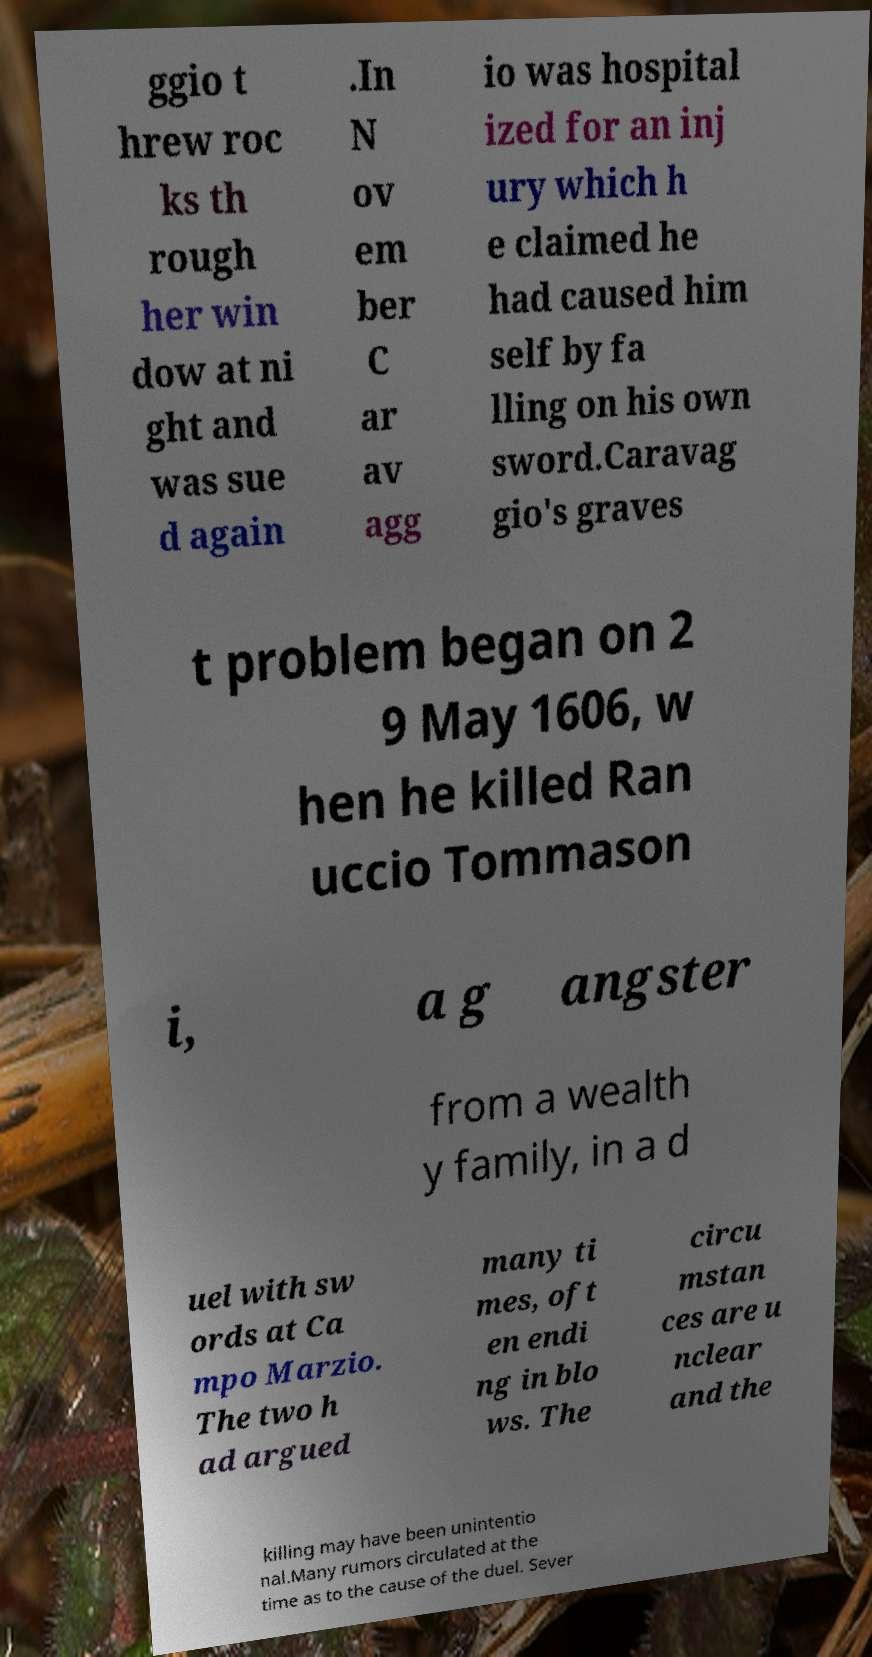I need the written content from this picture converted into text. Can you do that? ggio t hrew roc ks th rough her win dow at ni ght and was sue d again .In N ov em ber C ar av agg io was hospital ized for an inj ury which h e claimed he had caused him self by fa lling on his own sword.Caravag gio's graves t problem began on 2 9 May 1606, w hen he killed Ran uccio Tommason i, a g angster from a wealth y family, in a d uel with sw ords at Ca mpo Marzio. The two h ad argued many ti mes, oft en endi ng in blo ws. The circu mstan ces are u nclear and the killing may have been unintentio nal.Many rumors circulated at the time as to the cause of the duel. Sever 